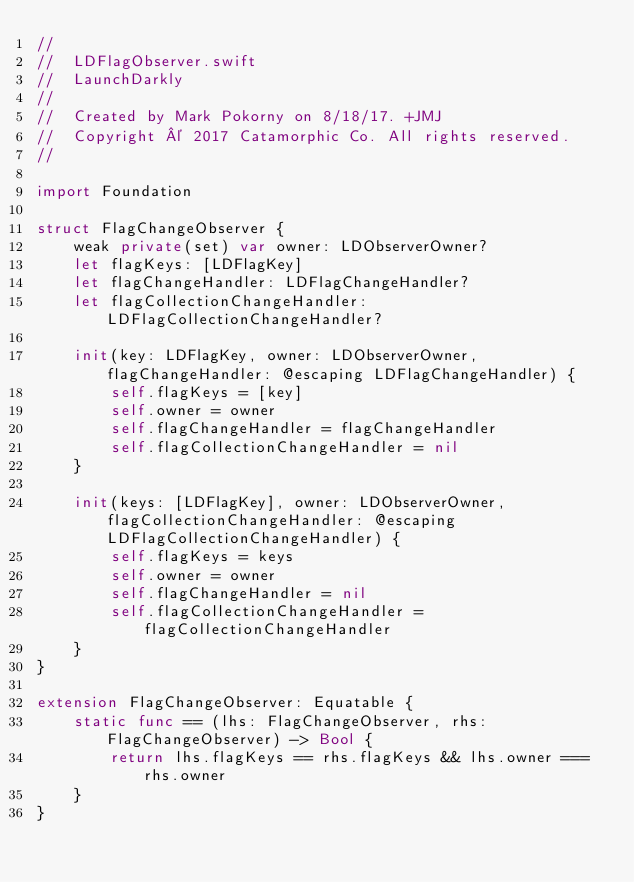Convert code to text. <code><loc_0><loc_0><loc_500><loc_500><_Swift_>//
//  LDFlagObserver.swift
//  LaunchDarkly
//
//  Created by Mark Pokorny on 8/18/17. +JMJ
//  Copyright © 2017 Catamorphic Co. All rights reserved.
//

import Foundation

struct FlagChangeObserver {
    weak private(set) var owner: LDObserverOwner?
    let flagKeys: [LDFlagKey]
    let flagChangeHandler: LDFlagChangeHandler?
    let flagCollectionChangeHandler: LDFlagCollectionChangeHandler?

    init(key: LDFlagKey, owner: LDObserverOwner, flagChangeHandler: @escaping LDFlagChangeHandler) {
        self.flagKeys = [key]
        self.owner = owner
        self.flagChangeHandler = flagChangeHandler
        self.flagCollectionChangeHandler = nil
    }

    init(keys: [LDFlagKey], owner: LDObserverOwner, flagCollectionChangeHandler: @escaping LDFlagCollectionChangeHandler) {
        self.flagKeys = keys
        self.owner = owner
        self.flagChangeHandler = nil
        self.flagCollectionChangeHandler = flagCollectionChangeHandler
    }
}

extension FlagChangeObserver: Equatable {
    static func == (lhs: FlagChangeObserver, rhs: FlagChangeObserver) -> Bool {
        return lhs.flagKeys == rhs.flagKeys && lhs.owner === rhs.owner
    }
}
</code> 